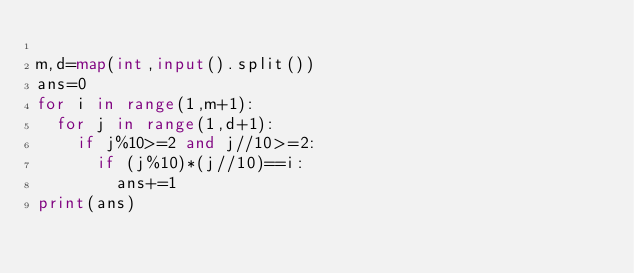<code> <loc_0><loc_0><loc_500><loc_500><_Python_>
m,d=map(int,input().split())
ans=0
for i in range(1,m+1):
  for j in range(1,d+1):
    if j%10>=2 and j//10>=2:
      if (j%10)*(j//10)==i:
        ans+=1
print(ans)</code> 